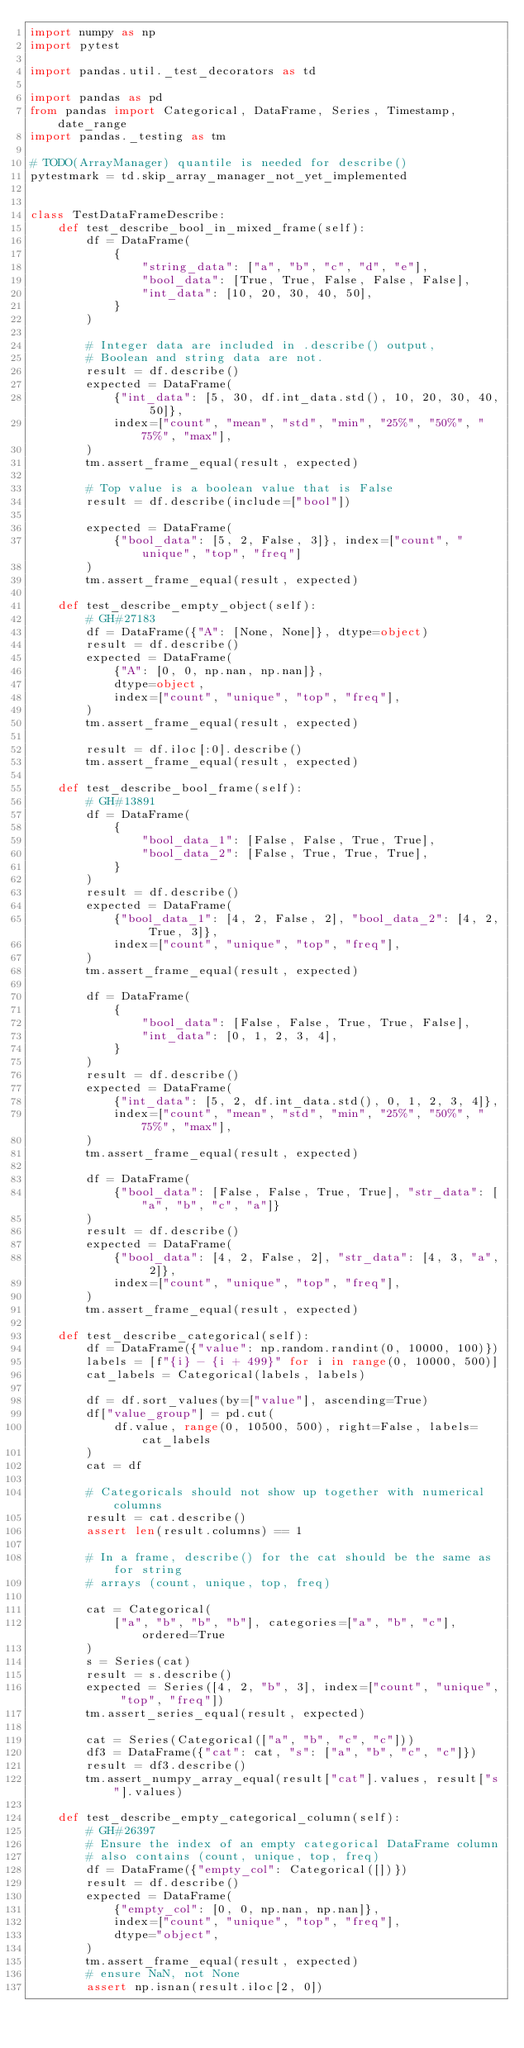Convert code to text. <code><loc_0><loc_0><loc_500><loc_500><_Python_>import numpy as np
import pytest

import pandas.util._test_decorators as td

import pandas as pd
from pandas import Categorical, DataFrame, Series, Timestamp, date_range
import pandas._testing as tm

# TODO(ArrayManager) quantile is needed for describe()
pytestmark = td.skip_array_manager_not_yet_implemented


class TestDataFrameDescribe:
    def test_describe_bool_in_mixed_frame(self):
        df = DataFrame(
            {
                "string_data": ["a", "b", "c", "d", "e"],
                "bool_data": [True, True, False, False, False],
                "int_data": [10, 20, 30, 40, 50],
            }
        )

        # Integer data are included in .describe() output,
        # Boolean and string data are not.
        result = df.describe()
        expected = DataFrame(
            {"int_data": [5, 30, df.int_data.std(), 10, 20, 30, 40, 50]},
            index=["count", "mean", "std", "min", "25%", "50%", "75%", "max"],
        )
        tm.assert_frame_equal(result, expected)

        # Top value is a boolean value that is False
        result = df.describe(include=["bool"])

        expected = DataFrame(
            {"bool_data": [5, 2, False, 3]}, index=["count", "unique", "top", "freq"]
        )
        tm.assert_frame_equal(result, expected)

    def test_describe_empty_object(self):
        # GH#27183
        df = DataFrame({"A": [None, None]}, dtype=object)
        result = df.describe()
        expected = DataFrame(
            {"A": [0, 0, np.nan, np.nan]},
            dtype=object,
            index=["count", "unique", "top", "freq"],
        )
        tm.assert_frame_equal(result, expected)

        result = df.iloc[:0].describe()
        tm.assert_frame_equal(result, expected)

    def test_describe_bool_frame(self):
        # GH#13891
        df = DataFrame(
            {
                "bool_data_1": [False, False, True, True],
                "bool_data_2": [False, True, True, True],
            }
        )
        result = df.describe()
        expected = DataFrame(
            {"bool_data_1": [4, 2, False, 2], "bool_data_2": [4, 2, True, 3]},
            index=["count", "unique", "top", "freq"],
        )
        tm.assert_frame_equal(result, expected)

        df = DataFrame(
            {
                "bool_data": [False, False, True, True, False],
                "int_data": [0, 1, 2, 3, 4],
            }
        )
        result = df.describe()
        expected = DataFrame(
            {"int_data": [5, 2, df.int_data.std(), 0, 1, 2, 3, 4]},
            index=["count", "mean", "std", "min", "25%", "50%", "75%", "max"],
        )
        tm.assert_frame_equal(result, expected)

        df = DataFrame(
            {"bool_data": [False, False, True, True], "str_data": ["a", "b", "c", "a"]}
        )
        result = df.describe()
        expected = DataFrame(
            {"bool_data": [4, 2, False, 2], "str_data": [4, 3, "a", 2]},
            index=["count", "unique", "top", "freq"],
        )
        tm.assert_frame_equal(result, expected)

    def test_describe_categorical(self):
        df = DataFrame({"value": np.random.randint(0, 10000, 100)})
        labels = [f"{i} - {i + 499}" for i in range(0, 10000, 500)]
        cat_labels = Categorical(labels, labels)

        df = df.sort_values(by=["value"], ascending=True)
        df["value_group"] = pd.cut(
            df.value, range(0, 10500, 500), right=False, labels=cat_labels
        )
        cat = df

        # Categoricals should not show up together with numerical columns
        result = cat.describe()
        assert len(result.columns) == 1

        # In a frame, describe() for the cat should be the same as for string
        # arrays (count, unique, top, freq)

        cat = Categorical(
            ["a", "b", "b", "b"], categories=["a", "b", "c"], ordered=True
        )
        s = Series(cat)
        result = s.describe()
        expected = Series([4, 2, "b", 3], index=["count", "unique", "top", "freq"])
        tm.assert_series_equal(result, expected)

        cat = Series(Categorical(["a", "b", "c", "c"]))
        df3 = DataFrame({"cat": cat, "s": ["a", "b", "c", "c"]})
        result = df3.describe()
        tm.assert_numpy_array_equal(result["cat"].values, result["s"].values)

    def test_describe_empty_categorical_column(self):
        # GH#26397
        # Ensure the index of an empty categorical DataFrame column
        # also contains (count, unique, top, freq)
        df = DataFrame({"empty_col": Categorical([])})
        result = df.describe()
        expected = DataFrame(
            {"empty_col": [0, 0, np.nan, np.nan]},
            index=["count", "unique", "top", "freq"],
            dtype="object",
        )
        tm.assert_frame_equal(result, expected)
        # ensure NaN, not None
        assert np.isnan(result.iloc[2, 0])</code> 